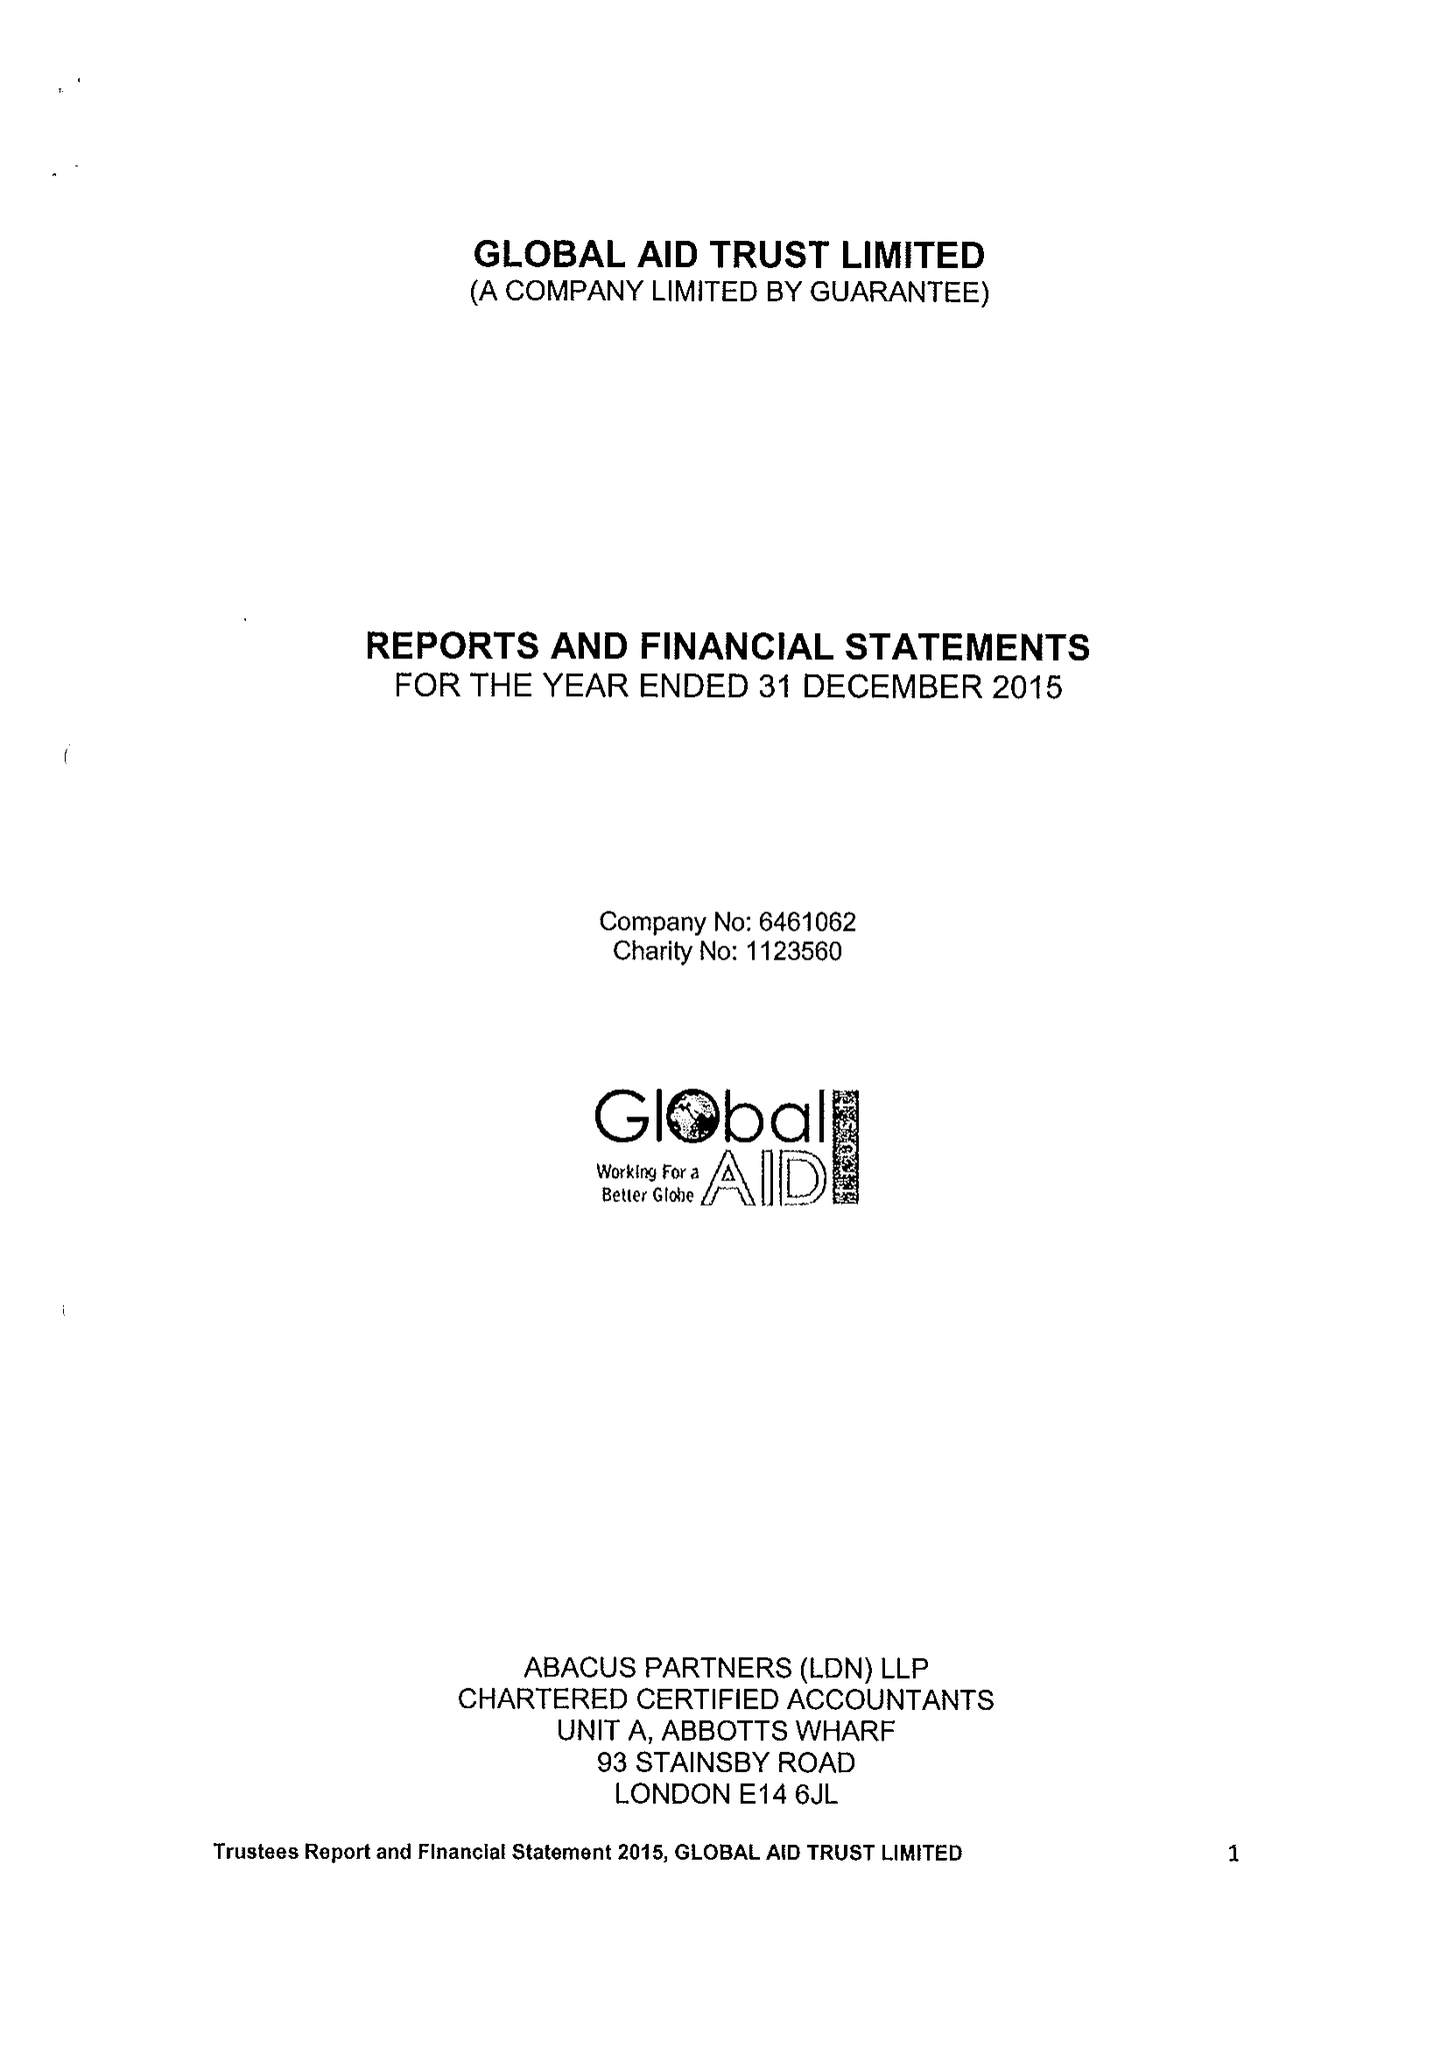What is the value for the address__postcode?
Answer the question using a single word or phrase. E1 2BJ 